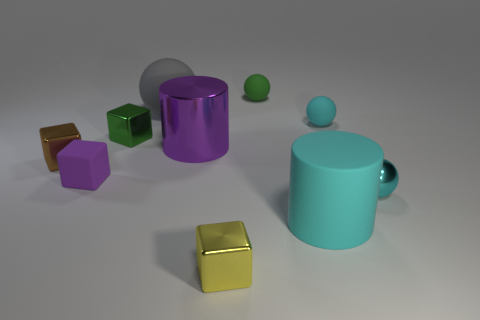What number of things are large cylinders on the right side of the large shiny cylinder or cyan metallic objects?
Offer a terse response. 2. What number of other things are the same shape as the large cyan thing?
Your response must be concise. 1. There is a matte object to the left of the tiny green metal thing; does it have the same shape as the tiny yellow object?
Keep it short and to the point. Yes. Are there any tiny shiny cubes left of the tiny purple block?
Ensure brevity in your answer.  Yes. How many large things are cyan objects or gray rubber things?
Ensure brevity in your answer.  2. Are the large sphere and the big cyan cylinder made of the same material?
Ensure brevity in your answer.  Yes. What is the size of the cylinder that is the same color as the tiny metallic ball?
Your answer should be compact. Large. Is there a matte cylinder of the same color as the tiny metallic ball?
Give a very brief answer. Yes. There is a purple thing that is made of the same material as the large gray sphere; what size is it?
Give a very brief answer. Small. There is a tiny cyan thing that is behind the tiny rubber object in front of the tiny block left of the small purple object; what is its shape?
Provide a short and direct response. Sphere. 